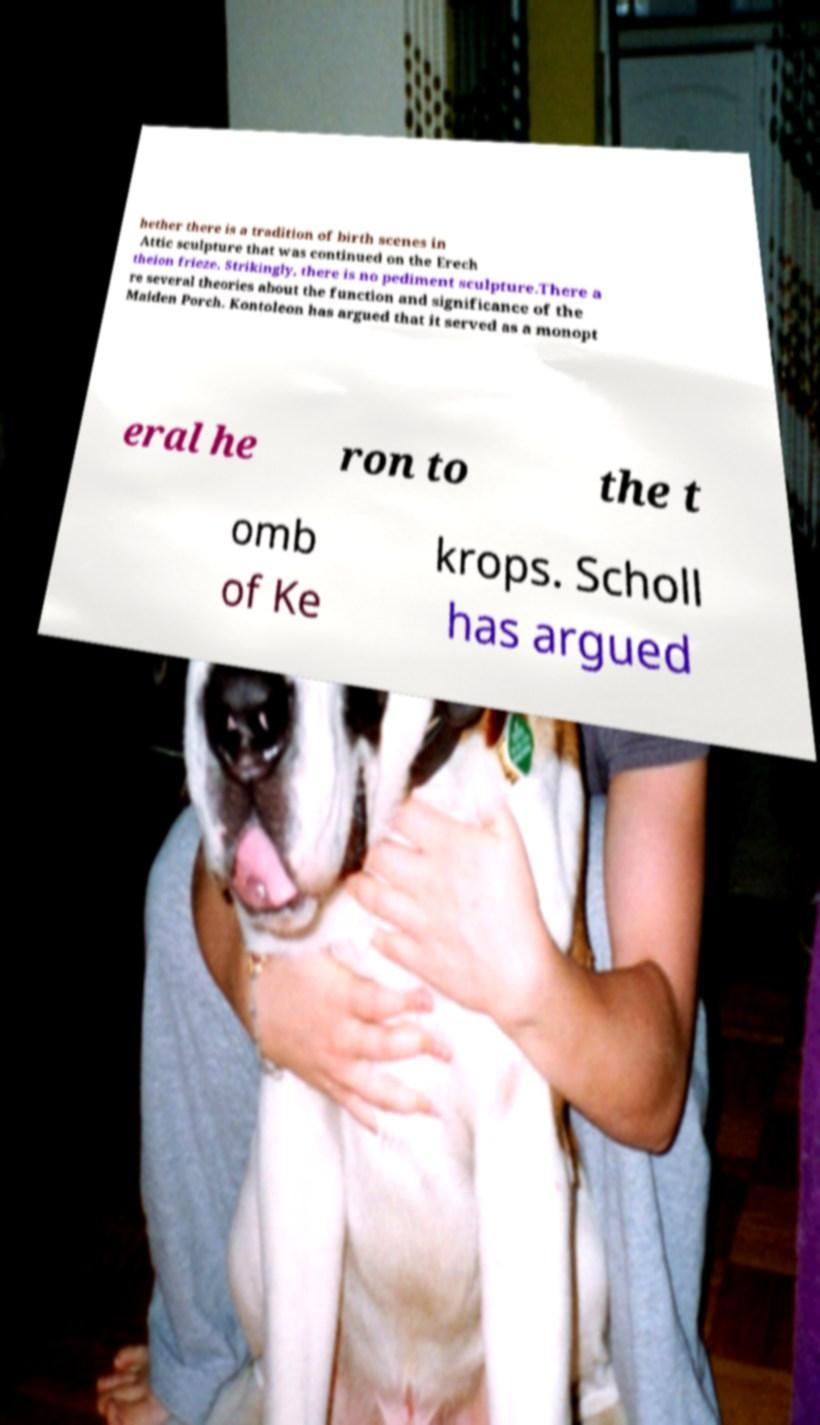For documentation purposes, I need the text within this image transcribed. Could you provide that? hether there is a tradition of birth scenes in Attic sculpture that was continued on the Erech theion frieze. Strikingly, there is no pediment sculpture.There a re several theories about the function and significance of the Maiden Porch. Kontoleon has argued that it served as a monopt eral he ron to the t omb of Ke krops. Scholl has argued 